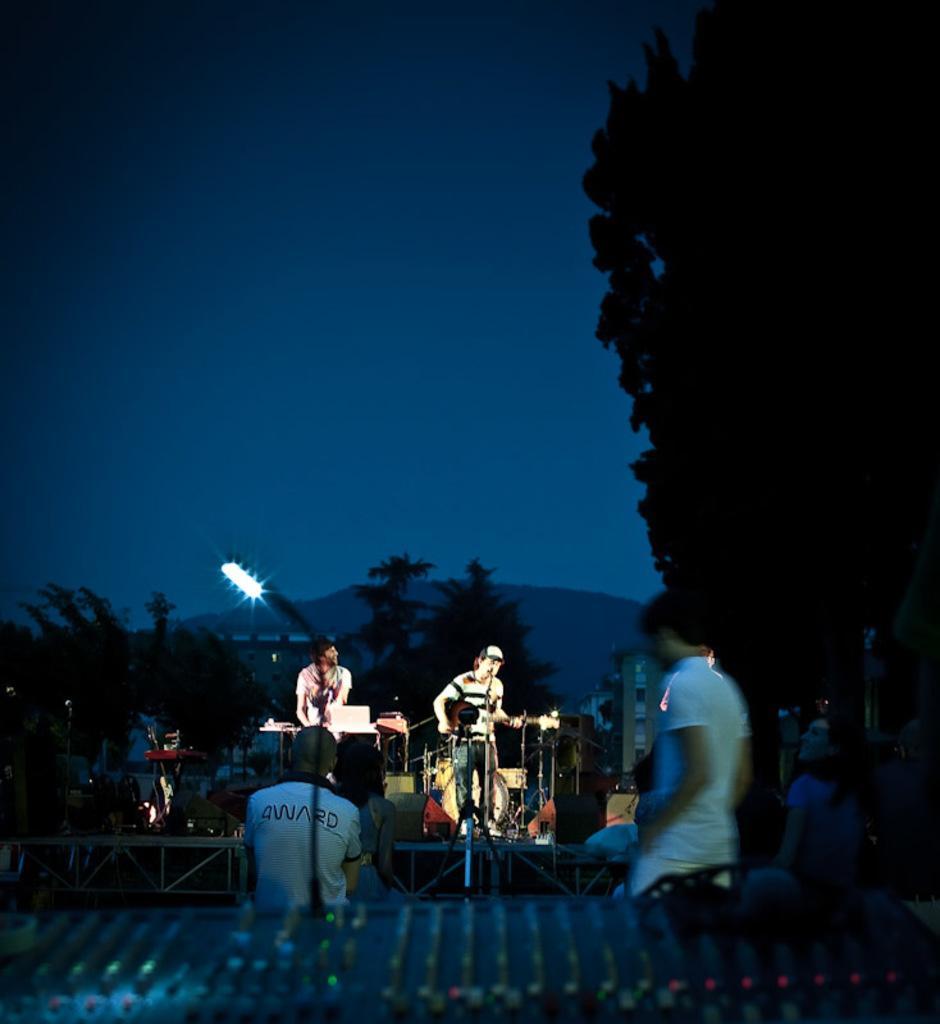Can you describe this image briefly? It is a music concert two people were playing the music and there are different instruments around them, in front of the musicians there are a group of people and there are many trees around that area, in the background there is a sky. 